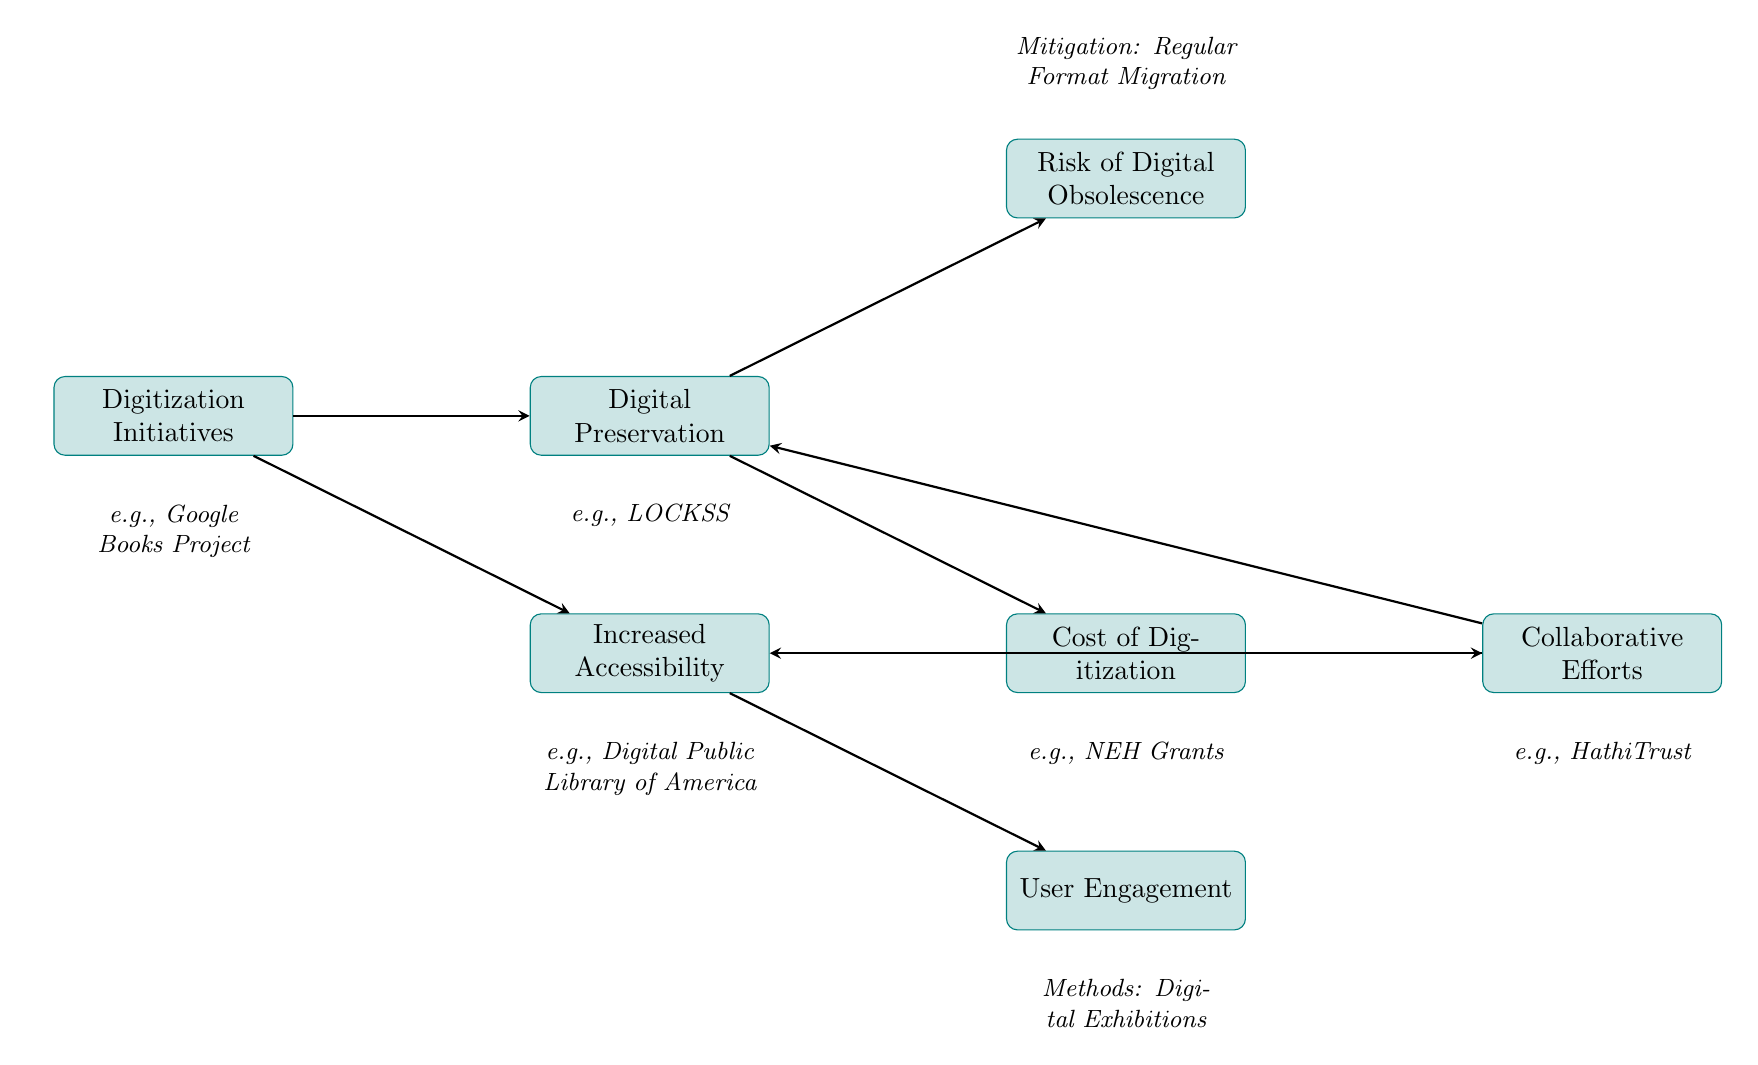What is the first node in the diagram? The first node is "Digitization Initiatives," which is positioned at the top and serves as the starting point for the flow of information in the diagram.
Answer: Digitization Initiatives How many nodes are in the diagram? There are seven nodes in the diagram, which represent different aspects of the impact of digitization on preservation.
Answer: 7 Which node represents the activities aimed at ensuring the longevity of digital documents? The node that represents these activities is "Digital Preservation," which focuses on keeping digital versions of historical documents safe and accessible.
Answer: Digital Preservation What is one example of a collaborative effort noted in the diagram? The example provided in the diagram for collaborative efforts includes "HathiTrust," which is an initiative involving multiple institutions working together to preserve and provide access to digital resources.
Answer: HathiTrust What type of user engagement is mentioned in the diagram? The diagram mentions "Digital Exhibitions" as a method of user engagement, highlighting how the public and scholars can interact with digital archives through curated displays.
Answer: Digital Exhibitions What node is directly connected to "Cost of Digitization"? The nodes directly connected to "Cost of Digitization" are "Collaborative Efforts" and "Digital Preservation," indicating collaboration may help alleviate costs and also suggesting a direct relationship with preserving digital formats.
Answer: Collaborative Efforts, Digital Preservation What mitigation strategy is suggested for the risk associated with digital formats? The strategy suggested for mitigating the risk of digital obsolescence is "Regular Format Migration," which involves updating digital documents to current formats to ensure continued accessibility.
Answer: Regular Format Migration Which two nodes have a direct relationship indicating increased accessibility leads to user engagement? The nodes with a direct relationship indicating this are "Increased Accessibility" and "User Engagement," which implies that better access to digital documents encourages public interaction.
Answer: Increased Accessibility, User Engagement 